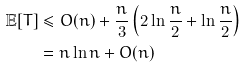<formula> <loc_0><loc_0><loc_500><loc_500>\mathbb { E } [ T ] & \leq O ( n ) + \frac { n } { 3 } \left ( 2 \ln \frac { n } { 2 } + \ln \frac { n } { 2 } \right ) \\ & = n \ln n + O ( n )</formula> 